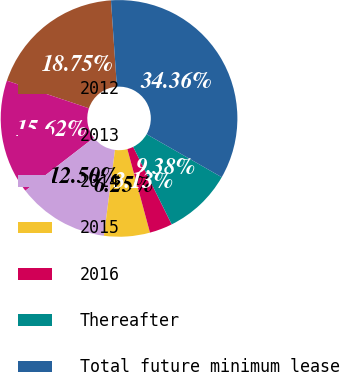<chart> <loc_0><loc_0><loc_500><loc_500><pie_chart><fcel>2012<fcel>2013<fcel>2014<fcel>2015<fcel>2016<fcel>Thereafter<fcel>Total future minimum lease<nl><fcel>18.75%<fcel>15.62%<fcel>12.5%<fcel>6.25%<fcel>3.13%<fcel>9.38%<fcel>34.36%<nl></chart> 